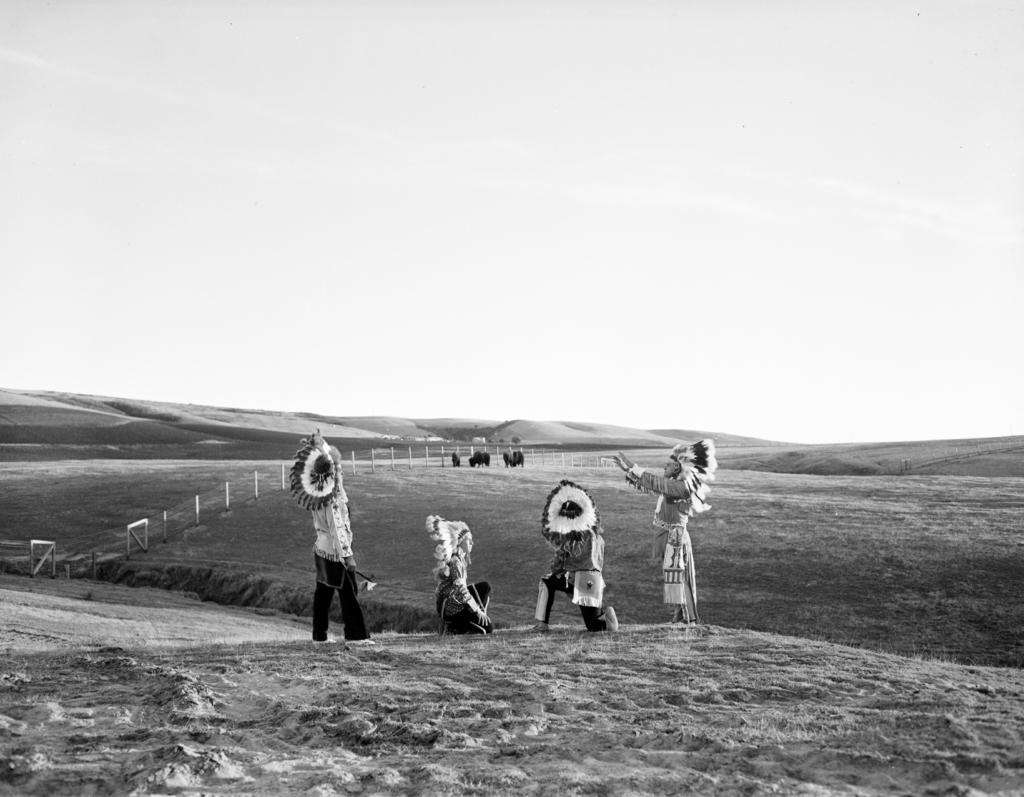How many people are present in the image? There are four people in the image. What else can be seen in the image besides the people? There are animals, fencing, mountains, and the sky visible in the image. What type of advertisement can be seen on the plate in the image? There is no plate present in the image, and therefore no advertisement can be observed. 